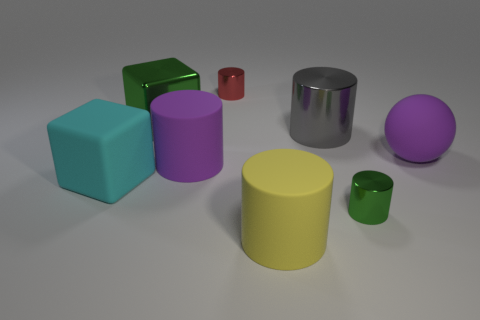Subtract 1 cylinders. How many cylinders are left? 4 Add 1 large purple shiny cylinders. How many objects exist? 9 Subtract all blocks. How many objects are left? 6 Subtract all yellow matte things. Subtract all big metal blocks. How many objects are left? 6 Add 2 large rubber cubes. How many large rubber cubes are left? 3 Add 8 shiny balls. How many shiny balls exist? 8 Subtract 1 green blocks. How many objects are left? 7 